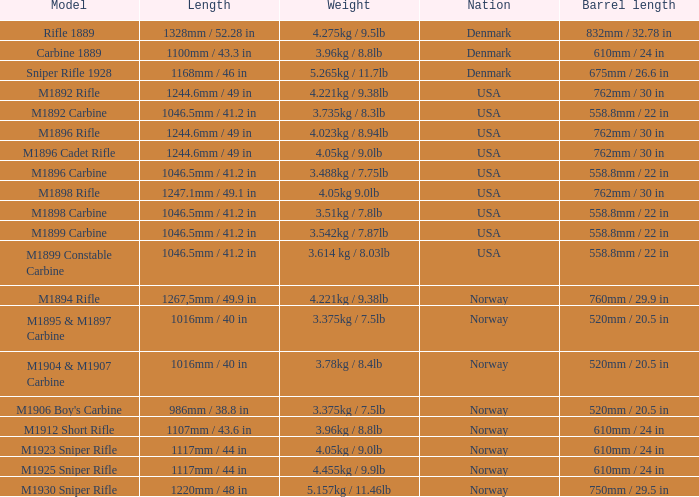What is Weight, when Length is 1168mm / 46 in? 5.265kg / 11.7lb. 